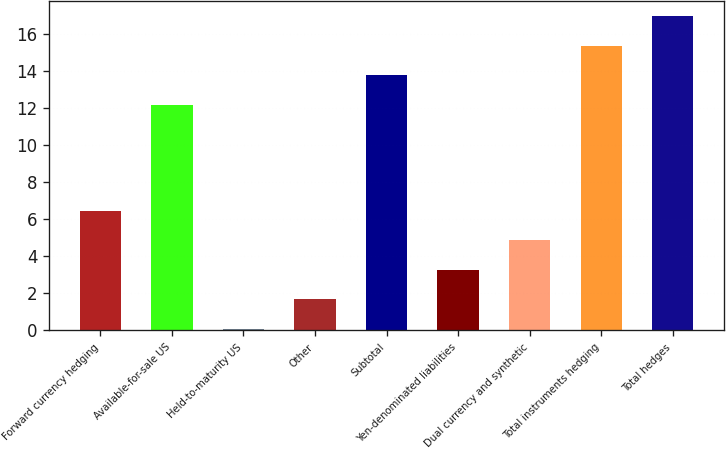<chart> <loc_0><loc_0><loc_500><loc_500><bar_chart><fcel>Forward currency hedging<fcel>Available-for-sale US<fcel>Held-to-maturity US<fcel>Other<fcel>Subtotal<fcel>Yen-denominated liabilities<fcel>Dual currency and synthetic<fcel>Total instruments hedging<fcel>Total hedges<nl><fcel>6.46<fcel>12.2<fcel>0.1<fcel>1.69<fcel>13.79<fcel>3.28<fcel>4.87<fcel>15.38<fcel>16.97<nl></chart> 